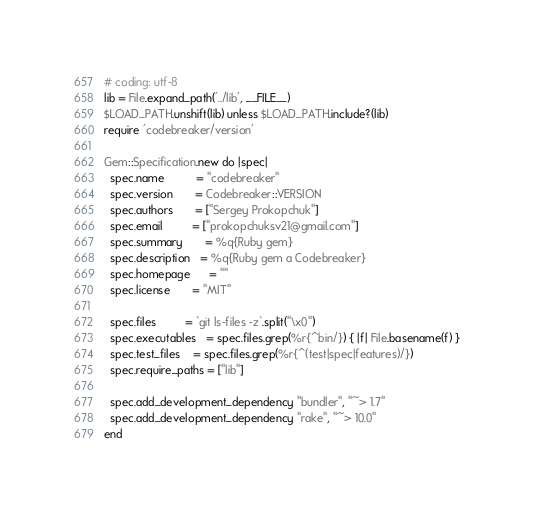Convert code to text. <code><loc_0><loc_0><loc_500><loc_500><_Ruby_># coding: utf-8
lib = File.expand_path('../lib', __FILE__)
$LOAD_PATH.unshift(lib) unless $LOAD_PATH.include?(lib)
require 'codebreaker/version'

Gem::Specification.new do |spec|
  spec.name          = "codebreaker"
  spec.version       = Codebreaker::VERSION
  spec.authors       = ["Sergey Prokopchuk"]
  spec.email         = ["prokopchuksv21@gmail.com"]
  spec.summary       = %q{Ruby gem}
  spec.description   = %q{Ruby gem a Codebreaker}
  spec.homepage      = ""
  spec.license       = "MIT"

  spec.files         = `git ls-files -z`.split("\x0")
  spec.executables   = spec.files.grep(%r{^bin/}) { |f| File.basename(f) }
  spec.test_files    = spec.files.grep(%r{^(test|spec|features)/})
  spec.require_paths = ["lib"]

  spec.add_development_dependency "bundler", "~> 1.7"
  spec.add_development_dependency "rake", "~> 10.0"
end
</code> 